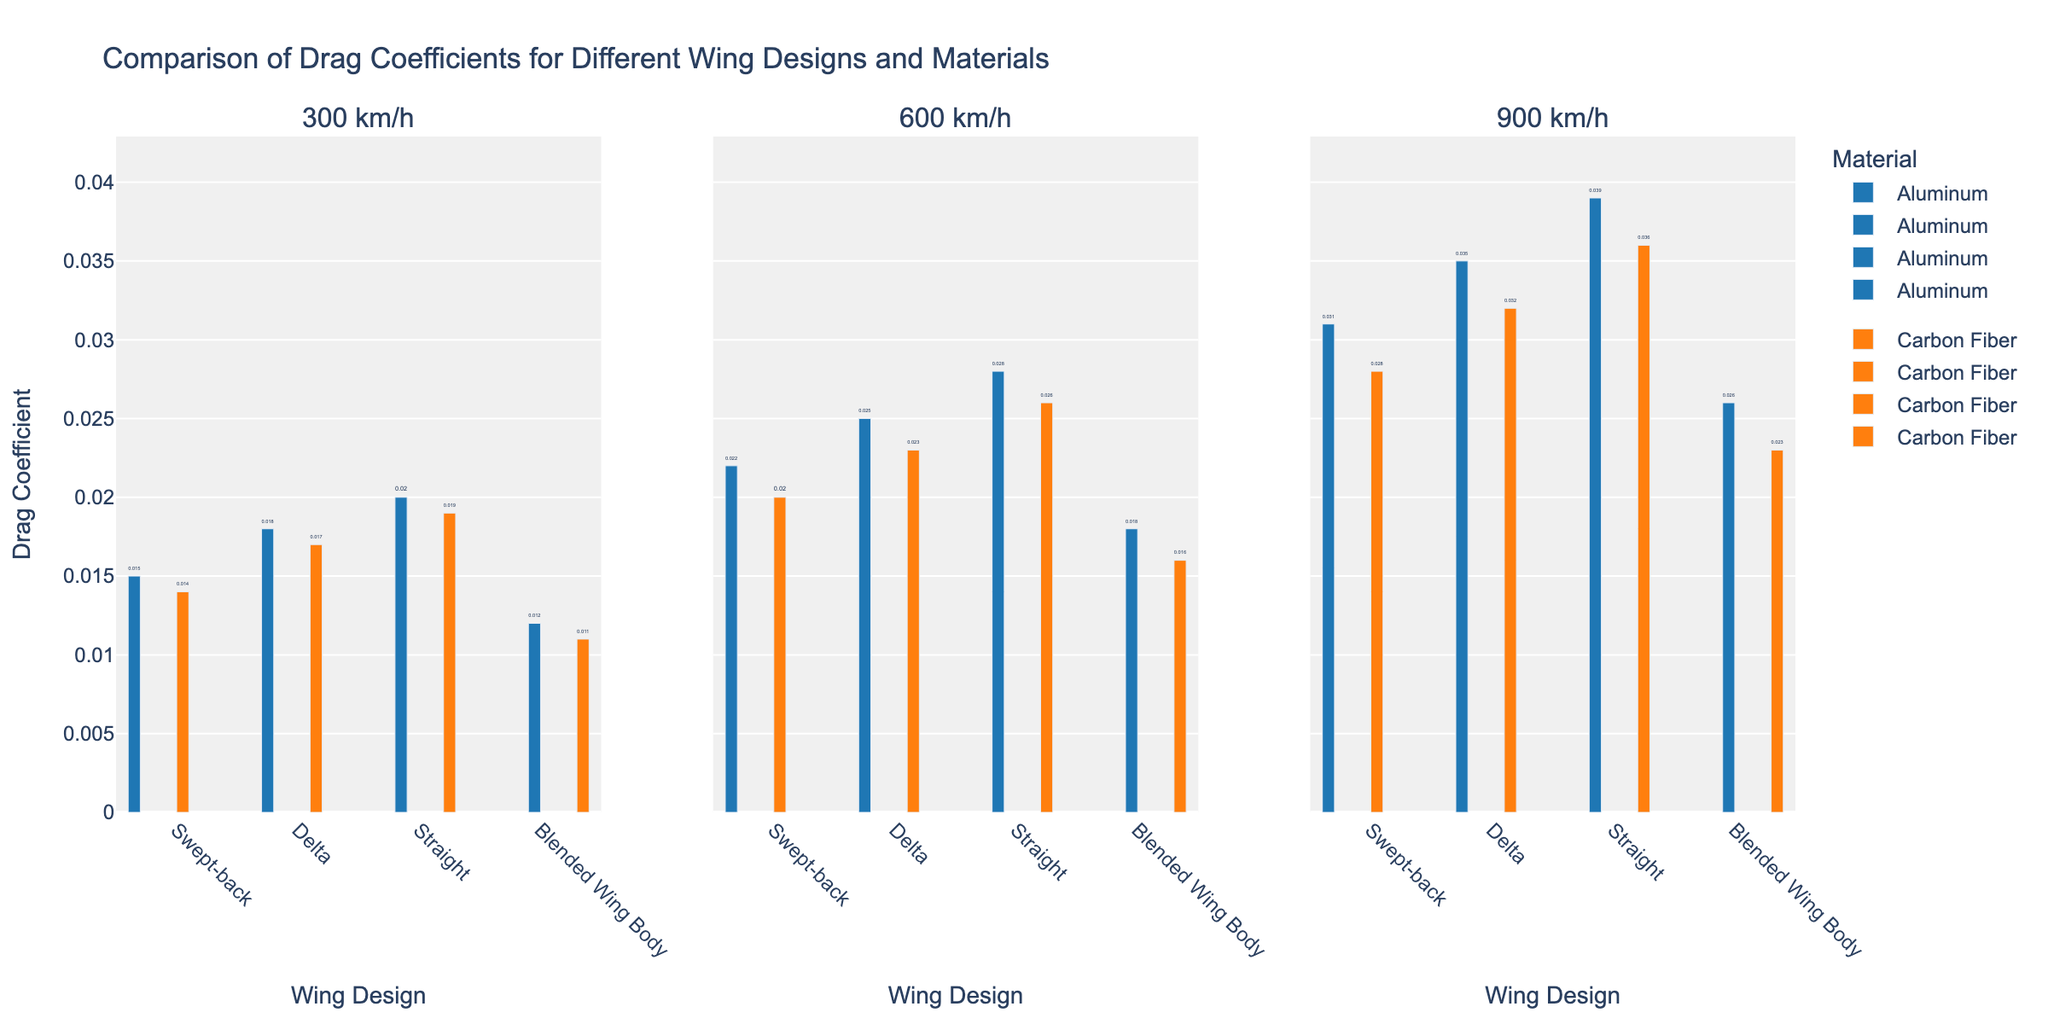Which wing design has the lowest drag coefficient at 900 km/h? To identify the wing design with the lowest drag coefficient at 900 km/h, look at the three subplots and compare the heights of the bars for 900 km/h. The wing design with the shortest bar will have the lowest drag coefficient. The Blended Wing Body with Carbon Fiber has the shortest bar, indicating it has the lowest drag coefficient.
Answer: Blended Wing Body (Carbon Fiber) How does the drag coefficient of the Delta wing design in Aluminum compare at 300 km/h and 600 km/h? First, find the bars representing the Delta wing design in Aluminum in the 300 km/h and 600 km/h subplots. The height of the bar at 300 km/h is 0.018, and at 600 km/h, it is 0.025. Compare these values to see that the drag coefficient at 600 km/h is higher.
Answer: Higher at 600 km/h What is the average drag coefficient for the Swept-back wing design in Carbon Fiber across all speeds? Take the values of the drag coefficients for the Swept-back wing design in Carbon Fiber across the speeds: 0.014 (300 km/h), 0.020 (600 km/h), and 0.028 (900 km/h). Calculate the average: (0.014 + 0.020 + 0.028) / 3 = 0.021.
Answer: 0.021 Does the drag coefficient of Straight designs in Carbon Fiber increase consistently with speed? Observe the bars representing drag coefficients for Straight designs in Carbon Fiber at 300 km/h, 600 km/h, and 900 km/h. Their heights are 0.019, 0.026, and 0.036 respectively. Since each value is larger than the previous, it indicates a consistent increase.
Answer: Yes Which material shows a lower overall drag coefficient for Blended Wing Body designs at 600 km/h? For Blended Wing Body designs at 600 km/h, compare the heights of the bars representing Aluminum and Carbon Fiber. The bar for Carbon Fiber is shorter, corresponding to a drag coefficient of 0.016, while Aluminum is 0.018.
Answer: Carbon Fiber By how much does the drag coefficient for Aluminum Swept-back designs increase from 300 km/h to 900 km/h? Find the drag coefficients for Aluminum Swept-back designs at 300 km/h (0.015) and 900 km/h (0.031). Calculate the difference: 0.031 - 0.015 = 0.016.
Answer: 0.016 Is there any wing design that has a smaller drag coefficient in Aluminum than Carbon Fiber at any speed? For each speed, compare drag coefficients for all wing designs in Aluminum and Carbon Fiber. Observe that for all instances and speeds, the Carbon Fiber always has drag coefficients equal to or lower than their Aluminum counterparts.
Answer: No 